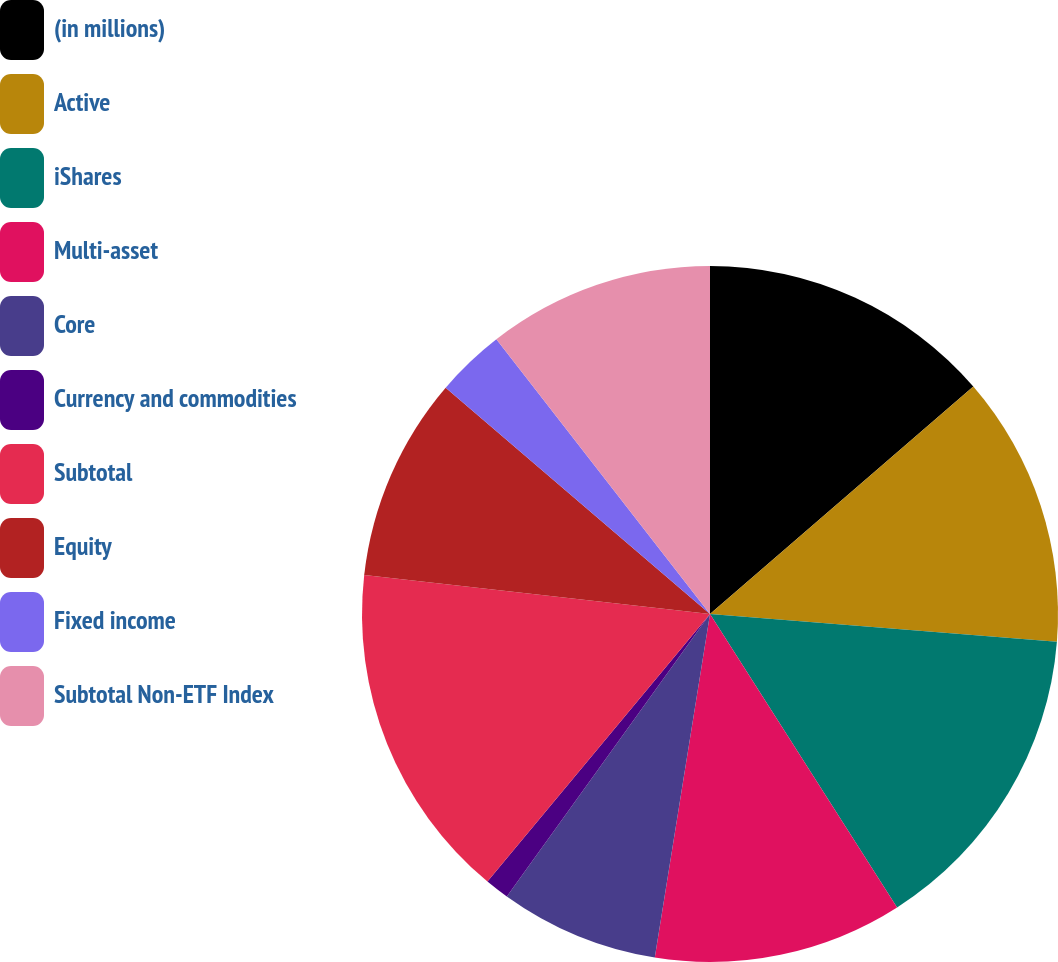Convert chart to OTSL. <chart><loc_0><loc_0><loc_500><loc_500><pie_chart><fcel>(in millions)<fcel>Active<fcel>iShares<fcel>Multi-asset<fcel>Core<fcel>Currency and commodities<fcel>Subtotal<fcel>Equity<fcel>Fixed income<fcel>Subtotal Non-ETF Index<nl><fcel>13.66%<fcel>12.61%<fcel>14.7%<fcel>11.57%<fcel>7.39%<fcel>1.12%<fcel>15.75%<fcel>9.48%<fcel>3.21%<fcel>10.52%<nl></chart> 